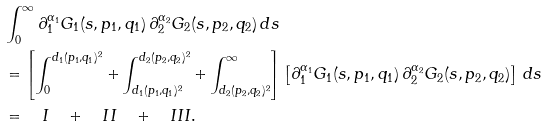<formula> <loc_0><loc_0><loc_500><loc_500>& \int _ { 0 } ^ { \infty } \partial ^ { \alpha _ { 1 } } _ { 1 } G _ { 1 } ( s , p _ { 1 } , q _ { 1 } ) \, \partial ^ { \alpha _ { 2 } } _ { 2 } G _ { 2 } ( s , p _ { 2 } , q _ { 2 } ) \, d s \\ & = \left [ \int _ { 0 } ^ { d _ { 1 } ( p _ { 1 } , q _ { 1 } ) ^ { 2 } } + \int _ { d _ { 1 } ( p _ { 1 } , q _ { 1 } ) ^ { 2 } } ^ { d _ { 2 } ( p _ { 2 } , q _ { 2 } ) ^ { 2 } } + \int _ { d _ { 2 } ( p _ { 2 } , q _ { 2 } ) ^ { 2 } } ^ { \infty } \right ] \left [ \partial ^ { \alpha _ { 1 } } _ { 1 } G _ { 1 } ( s , p _ { 1 } , q _ { 1 } ) \, \partial ^ { \alpha _ { 2 } } _ { 2 } G _ { 2 } ( s , p _ { 2 } , q _ { 2 } ) \right ] \, d s \\ & = \quad I \quad + \quad I I \quad + \quad I I I .</formula> 